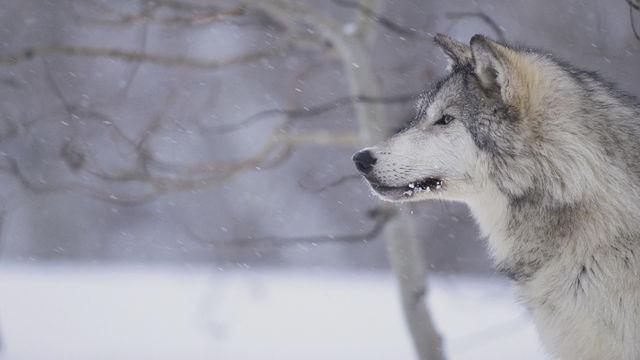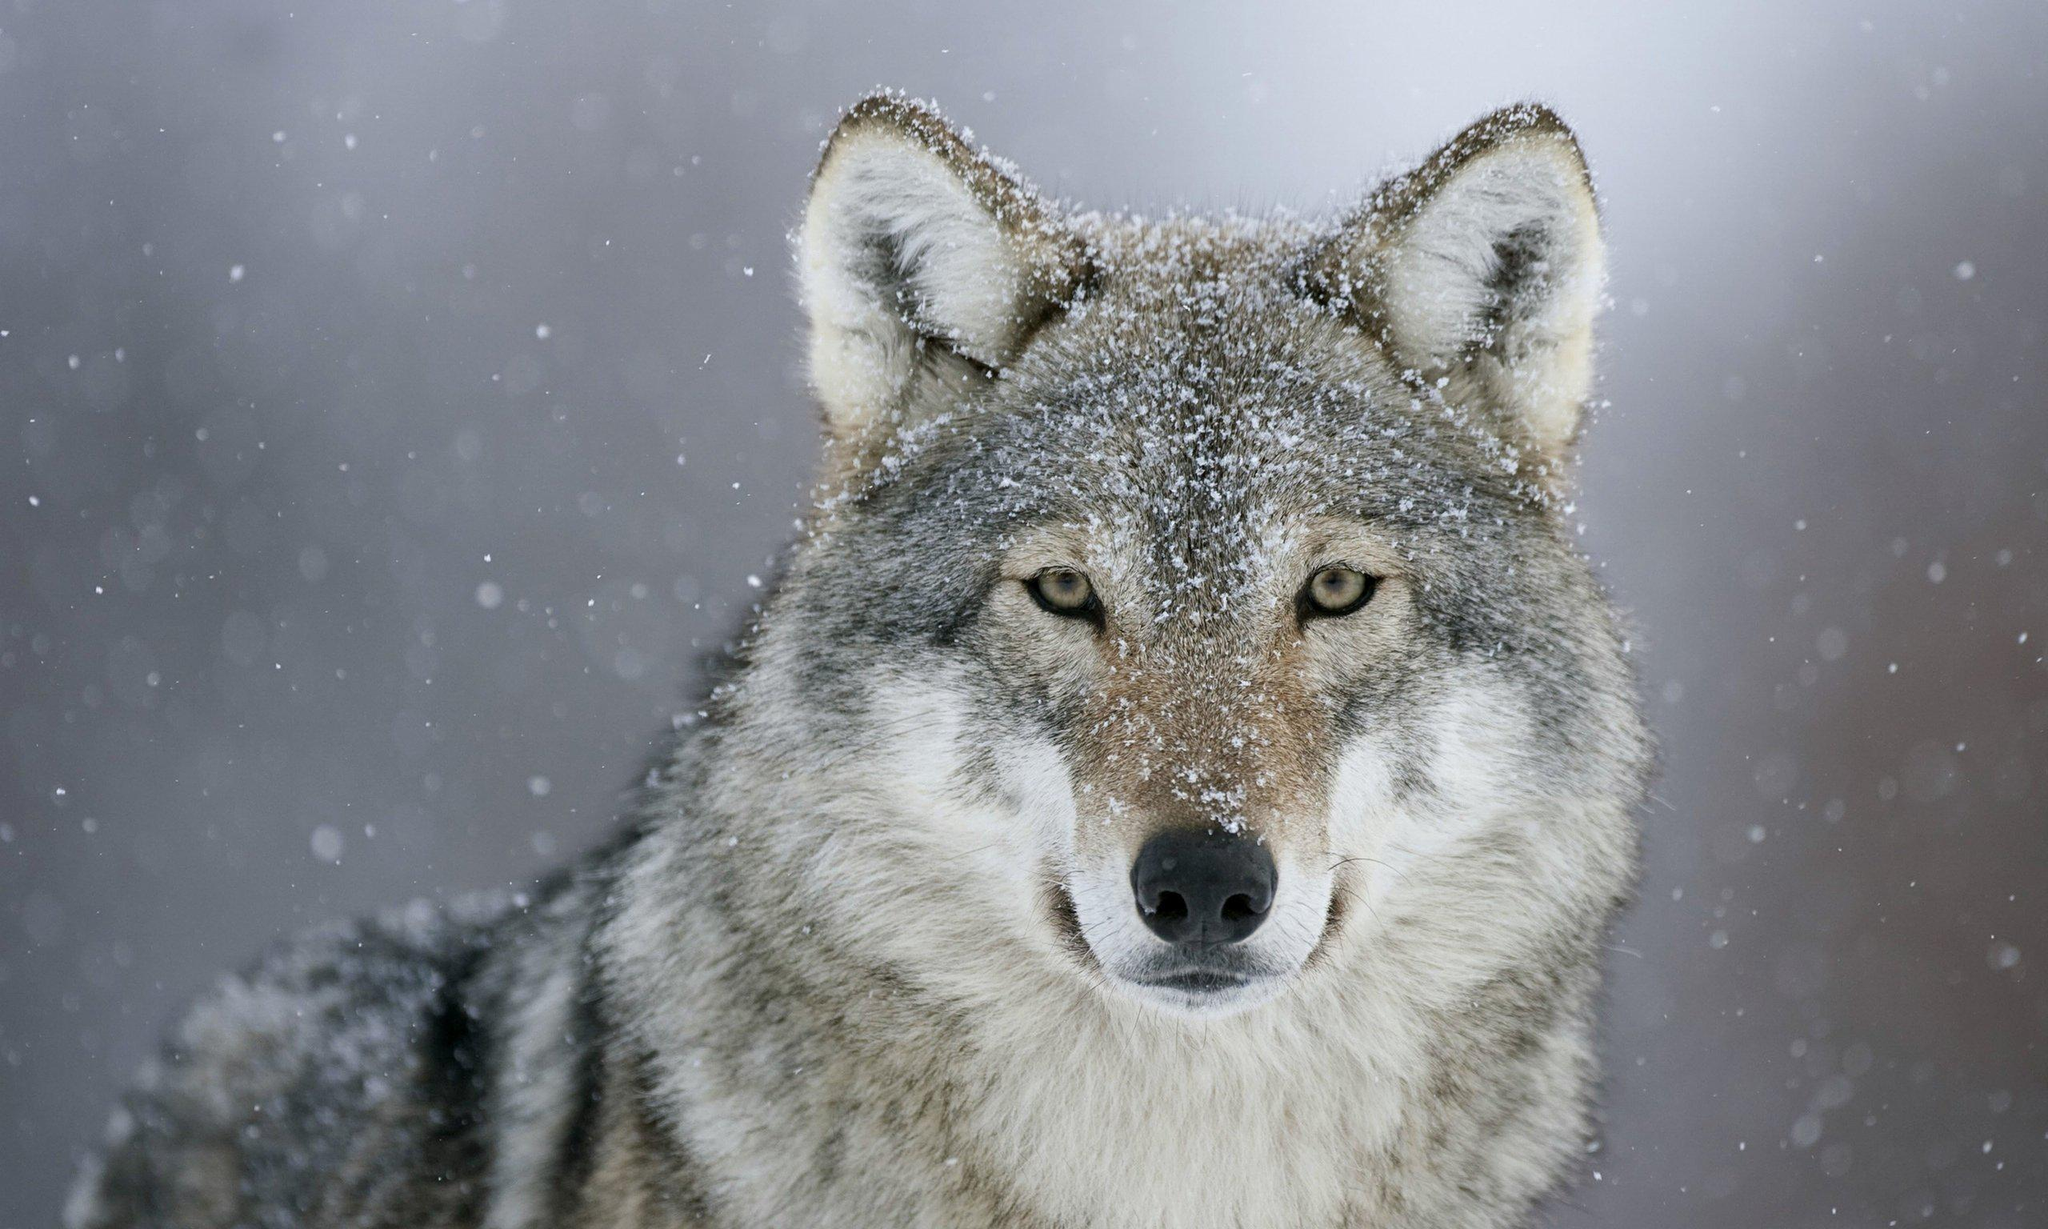The first image is the image on the left, the second image is the image on the right. Examine the images to the left and right. Is the description "The animal in the image on the right has a white coat." accurate? Answer yes or no. No. 